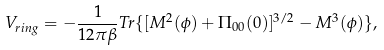<formula> <loc_0><loc_0><loc_500><loc_500>V _ { r i n g } = - \frac { 1 } { 1 2 \pi \beta } T r \{ [ M ^ { 2 } ( \phi ) + \Pi _ { 0 0 } ( 0 ) ] ^ { 3 / 2 } - M ^ { 3 } ( \phi ) \} ,</formula> 